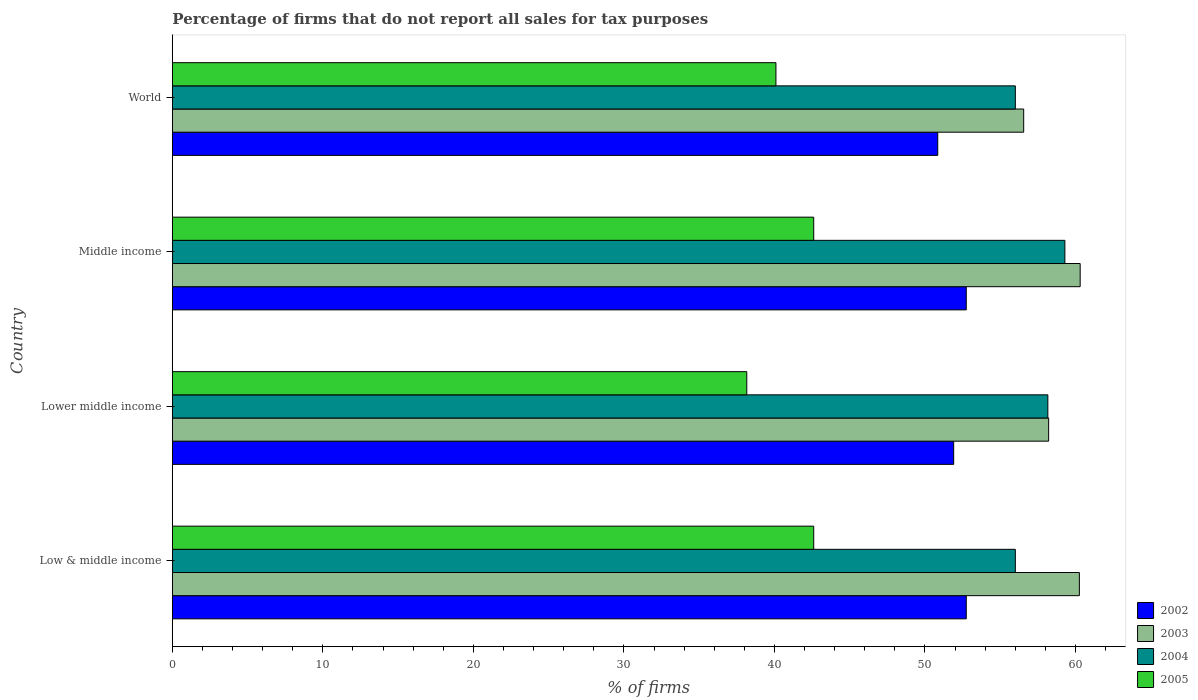Are the number of bars on each tick of the Y-axis equal?
Make the answer very short. Yes. How many bars are there on the 3rd tick from the bottom?
Offer a terse response. 4. What is the label of the 3rd group of bars from the top?
Ensure brevity in your answer.  Lower middle income. What is the percentage of firms that do not report all sales for tax purposes in 2002 in World?
Offer a very short reply. 50.85. Across all countries, what is the maximum percentage of firms that do not report all sales for tax purposes in 2004?
Provide a succinct answer. 59.3. Across all countries, what is the minimum percentage of firms that do not report all sales for tax purposes in 2002?
Provide a succinct answer. 50.85. In which country was the percentage of firms that do not report all sales for tax purposes in 2005 minimum?
Make the answer very short. Lower middle income. What is the total percentage of firms that do not report all sales for tax purposes in 2005 in the graph?
Provide a succinct answer. 163.48. What is the difference between the percentage of firms that do not report all sales for tax purposes in 2003 in Low & middle income and that in Lower middle income?
Provide a short and direct response. 2.04. What is the difference between the percentage of firms that do not report all sales for tax purposes in 2002 in Lower middle income and the percentage of firms that do not report all sales for tax purposes in 2003 in Middle income?
Offer a terse response. -8.4. What is the average percentage of firms that do not report all sales for tax purposes in 2003 per country?
Make the answer very short. 58.84. What is the difference between the percentage of firms that do not report all sales for tax purposes in 2003 and percentage of firms that do not report all sales for tax purposes in 2002 in World?
Your response must be concise. 5.71. In how many countries, is the percentage of firms that do not report all sales for tax purposes in 2002 greater than 26 %?
Offer a very short reply. 4. What is the ratio of the percentage of firms that do not report all sales for tax purposes in 2004 in Lower middle income to that in Middle income?
Your answer should be compact. 0.98. What is the difference between the highest and the second highest percentage of firms that do not report all sales for tax purposes in 2002?
Provide a succinct answer. 0. What is the difference between the highest and the lowest percentage of firms that do not report all sales for tax purposes in 2003?
Offer a very short reply. 3.75. In how many countries, is the percentage of firms that do not report all sales for tax purposes in 2005 greater than the average percentage of firms that do not report all sales for tax purposes in 2005 taken over all countries?
Make the answer very short. 2. Is the sum of the percentage of firms that do not report all sales for tax purposes in 2003 in Lower middle income and World greater than the maximum percentage of firms that do not report all sales for tax purposes in 2005 across all countries?
Provide a succinct answer. Yes. What does the 1st bar from the bottom in World represents?
Provide a succinct answer. 2002. Is it the case that in every country, the sum of the percentage of firms that do not report all sales for tax purposes in 2004 and percentage of firms that do not report all sales for tax purposes in 2005 is greater than the percentage of firms that do not report all sales for tax purposes in 2003?
Ensure brevity in your answer.  Yes. How many bars are there?
Your answer should be compact. 16. Are all the bars in the graph horizontal?
Provide a short and direct response. Yes. What is the difference between two consecutive major ticks on the X-axis?
Offer a terse response. 10. Are the values on the major ticks of X-axis written in scientific E-notation?
Your answer should be compact. No. Does the graph contain any zero values?
Offer a very short reply. No. Does the graph contain grids?
Make the answer very short. No. What is the title of the graph?
Your response must be concise. Percentage of firms that do not report all sales for tax purposes. Does "2013" appear as one of the legend labels in the graph?
Provide a short and direct response. No. What is the label or title of the X-axis?
Give a very brief answer. % of firms. What is the % of firms in 2002 in Low & middle income?
Ensure brevity in your answer.  52.75. What is the % of firms in 2003 in Low & middle income?
Provide a short and direct response. 60.26. What is the % of firms of 2004 in Low & middle income?
Offer a terse response. 56.01. What is the % of firms of 2005 in Low & middle income?
Provide a succinct answer. 42.61. What is the % of firms of 2002 in Lower middle income?
Provide a succinct answer. 51.91. What is the % of firms of 2003 in Lower middle income?
Provide a succinct answer. 58.22. What is the % of firms of 2004 in Lower middle income?
Make the answer very short. 58.16. What is the % of firms of 2005 in Lower middle income?
Your answer should be very brief. 38.16. What is the % of firms in 2002 in Middle income?
Offer a terse response. 52.75. What is the % of firms in 2003 in Middle income?
Make the answer very short. 60.31. What is the % of firms in 2004 in Middle income?
Make the answer very short. 59.3. What is the % of firms in 2005 in Middle income?
Give a very brief answer. 42.61. What is the % of firms in 2002 in World?
Your answer should be very brief. 50.85. What is the % of firms of 2003 in World?
Keep it short and to the point. 56.56. What is the % of firms of 2004 in World?
Offer a terse response. 56.01. What is the % of firms of 2005 in World?
Your answer should be compact. 40.1. Across all countries, what is the maximum % of firms of 2002?
Your response must be concise. 52.75. Across all countries, what is the maximum % of firms of 2003?
Provide a succinct answer. 60.31. Across all countries, what is the maximum % of firms of 2004?
Provide a succinct answer. 59.3. Across all countries, what is the maximum % of firms of 2005?
Give a very brief answer. 42.61. Across all countries, what is the minimum % of firms in 2002?
Keep it short and to the point. 50.85. Across all countries, what is the minimum % of firms in 2003?
Ensure brevity in your answer.  56.56. Across all countries, what is the minimum % of firms of 2004?
Offer a very short reply. 56.01. Across all countries, what is the minimum % of firms of 2005?
Give a very brief answer. 38.16. What is the total % of firms of 2002 in the graph?
Keep it short and to the point. 208.25. What is the total % of firms in 2003 in the graph?
Keep it short and to the point. 235.35. What is the total % of firms of 2004 in the graph?
Your response must be concise. 229.47. What is the total % of firms in 2005 in the graph?
Make the answer very short. 163.48. What is the difference between the % of firms of 2002 in Low & middle income and that in Lower middle income?
Your answer should be compact. 0.84. What is the difference between the % of firms of 2003 in Low & middle income and that in Lower middle income?
Offer a terse response. 2.04. What is the difference between the % of firms of 2004 in Low & middle income and that in Lower middle income?
Ensure brevity in your answer.  -2.16. What is the difference between the % of firms in 2005 in Low & middle income and that in Lower middle income?
Offer a terse response. 4.45. What is the difference between the % of firms of 2002 in Low & middle income and that in Middle income?
Your response must be concise. 0. What is the difference between the % of firms of 2003 in Low & middle income and that in Middle income?
Offer a terse response. -0.05. What is the difference between the % of firms of 2004 in Low & middle income and that in Middle income?
Your response must be concise. -3.29. What is the difference between the % of firms in 2005 in Low & middle income and that in Middle income?
Your response must be concise. 0. What is the difference between the % of firms in 2002 in Low & middle income and that in World?
Your response must be concise. 1.89. What is the difference between the % of firms in 2005 in Low & middle income and that in World?
Keep it short and to the point. 2.51. What is the difference between the % of firms in 2002 in Lower middle income and that in Middle income?
Ensure brevity in your answer.  -0.84. What is the difference between the % of firms of 2003 in Lower middle income and that in Middle income?
Make the answer very short. -2.09. What is the difference between the % of firms in 2004 in Lower middle income and that in Middle income?
Your answer should be very brief. -1.13. What is the difference between the % of firms of 2005 in Lower middle income and that in Middle income?
Give a very brief answer. -4.45. What is the difference between the % of firms in 2002 in Lower middle income and that in World?
Your answer should be very brief. 1.06. What is the difference between the % of firms of 2003 in Lower middle income and that in World?
Keep it short and to the point. 1.66. What is the difference between the % of firms of 2004 in Lower middle income and that in World?
Your response must be concise. 2.16. What is the difference between the % of firms of 2005 in Lower middle income and that in World?
Your answer should be very brief. -1.94. What is the difference between the % of firms in 2002 in Middle income and that in World?
Make the answer very short. 1.89. What is the difference between the % of firms in 2003 in Middle income and that in World?
Your response must be concise. 3.75. What is the difference between the % of firms in 2004 in Middle income and that in World?
Provide a succinct answer. 3.29. What is the difference between the % of firms of 2005 in Middle income and that in World?
Keep it short and to the point. 2.51. What is the difference between the % of firms of 2002 in Low & middle income and the % of firms of 2003 in Lower middle income?
Make the answer very short. -5.47. What is the difference between the % of firms of 2002 in Low & middle income and the % of firms of 2004 in Lower middle income?
Keep it short and to the point. -5.42. What is the difference between the % of firms of 2002 in Low & middle income and the % of firms of 2005 in Lower middle income?
Keep it short and to the point. 14.58. What is the difference between the % of firms of 2003 in Low & middle income and the % of firms of 2004 in Lower middle income?
Provide a short and direct response. 2.1. What is the difference between the % of firms of 2003 in Low & middle income and the % of firms of 2005 in Lower middle income?
Provide a succinct answer. 22.1. What is the difference between the % of firms of 2004 in Low & middle income and the % of firms of 2005 in Lower middle income?
Provide a short and direct response. 17.84. What is the difference between the % of firms in 2002 in Low & middle income and the % of firms in 2003 in Middle income?
Offer a very short reply. -7.57. What is the difference between the % of firms in 2002 in Low & middle income and the % of firms in 2004 in Middle income?
Offer a terse response. -6.55. What is the difference between the % of firms in 2002 in Low & middle income and the % of firms in 2005 in Middle income?
Your answer should be compact. 10.13. What is the difference between the % of firms in 2003 in Low & middle income and the % of firms in 2004 in Middle income?
Provide a succinct answer. 0.96. What is the difference between the % of firms in 2003 in Low & middle income and the % of firms in 2005 in Middle income?
Provide a short and direct response. 17.65. What is the difference between the % of firms in 2004 in Low & middle income and the % of firms in 2005 in Middle income?
Provide a short and direct response. 13.39. What is the difference between the % of firms of 2002 in Low & middle income and the % of firms of 2003 in World?
Keep it short and to the point. -3.81. What is the difference between the % of firms of 2002 in Low & middle income and the % of firms of 2004 in World?
Offer a terse response. -3.26. What is the difference between the % of firms in 2002 in Low & middle income and the % of firms in 2005 in World?
Your answer should be very brief. 12.65. What is the difference between the % of firms of 2003 in Low & middle income and the % of firms of 2004 in World?
Your answer should be very brief. 4.25. What is the difference between the % of firms of 2003 in Low & middle income and the % of firms of 2005 in World?
Offer a very short reply. 20.16. What is the difference between the % of firms in 2004 in Low & middle income and the % of firms in 2005 in World?
Your answer should be compact. 15.91. What is the difference between the % of firms in 2002 in Lower middle income and the % of firms in 2003 in Middle income?
Keep it short and to the point. -8.4. What is the difference between the % of firms in 2002 in Lower middle income and the % of firms in 2004 in Middle income?
Give a very brief answer. -7.39. What is the difference between the % of firms in 2002 in Lower middle income and the % of firms in 2005 in Middle income?
Your answer should be compact. 9.3. What is the difference between the % of firms in 2003 in Lower middle income and the % of firms in 2004 in Middle income?
Your answer should be very brief. -1.08. What is the difference between the % of firms in 2003 in Lower middle income and the % of firms in 2005 in Middle income?
Your response must be concise. 15.61. What is the difference between the % of firms of 2004 in Lower middle income and the % of firms of 2005 in Middle income?
Provide a succinct answer. 15.55. What is the difference between the % of firms of 2002 in Lower middle income and the % of firms of 2003 in World?
Your answer should be very brief. -4.65. What is the difference between the % of firms of 2002 in Lower middle income and the % of firms of 2004 in World?
Your response must be concise. -4.1. What is the difference between the % of firms in 2002 in Lower middle income and the % of firms in 2005 in World?
Your answer should be very brief. 11.81. What is the difference between the % of firms in 2003 in Lower middle income and the % of firms in 2004 in World?
Make the answer very short. 2.21. What is the difference between the % of firms of 2003 in Lower middle income and the % of firms of 2005 in World?
Make the answer very short. 18.12. What is the difference between the % of firms of 2004 in Lower middle income and the % of firms of 2005 in World?
Give a very brief answer. 18.07. What is the difference between the % of firms in 2002 in Middle income and the % of firms in 2003 in World?
Offer a very short reply. -3.81. What is the difference between the % of firms in 2002 in Middle income and the % of firms in 2004 in World?
Provide a short and direct response. -3.26. What is the difference between the % of firms of 2002 in Middle income and the % of firms of 2005 in World?
Keep it short and to the point. 12.65. What is the difference between the % of firms in 2003 in Middle income and the % of firms in 2004 in World?
Ensure brevity in your answer.  4.31. What is the difference between the % of firms of 2003 in Middle income and the % of firms of 2005 in World?
Provide a succinct answer. 20.21. What is the difference between the % of firms of 2004 in Middle income and the % of firms of 2005 in World?
Provide a succinct answer. 19.2. What is the average % of firms of 2002 per country?
Keep it short and to the point. 52.06. What is the average % of firms of 2003 per country?
Your answer should be compact. 58.84. What is the average % of firms of 2004 per country?
Ensure brevity in your answer.  57.37. What is the average % of firms in 2005 per country?
Your response must be concise. 40.87. What is the difference between the % of firms in 2002 and % of firms in 2003 in Low & middle income?
Provide a short and direct response. -7.51. What is the difference between the % of firms in 2002 and % of firms in 2004 in Low & middle income?
Your answer should be very brief. -3.26. What is the difference between the % of firms in 2002 and % of firms in 2005 in Low & middle income?
Provide a succinct answer. 10.13. What is the difference between the % of firms in 2003 and % of firms in 2004 in Low & middle income?
Your answer should be compact. 4.25. What is the difference between the % of firms in 2003 and % of firms in 2005 in Low & middle income?
Provide a succinct answer. 17.65. What is the difference between the % of firms in 2004 and % of firms in 2005 in Low & middle income?
Provide a succinct answer. 13.39. What is the difference between the % of firms of 2002 and % of firms of 2003 in Lower middle income?
Offer a terse response. -6.31. What is the difference between the % of firms in 2002 and % of firms in 2004 in Lower middle income?
Ensure brevity in your answer.  -6.26. What is the difference between the % of firms in 2002 and % of firms in 2005 in Lower middle income?
Ensure brevity in your answer.  13.75. What is the difference between the % of firms of 2003 and % of firms of 2004 in Lower middle income?
Ensure brevity in your answer.  0.05. What is the difference between the % of firms in 2003 and % of firms in 2005 in Lower middle income?
Give a very brief answer. 20.06. What is the difference between the % of firms of 2004 and % of firms of 2005 in Lower middle income?
Give a very brief answer. 20. What is the difference between the % of firms in 2002 and % of firms in 2003 in Middle income?
Your answer should be very brief. -7.57. What is the difference between the % of firms in 2002 and % of firms in 2004 in Middle income?
Provide a short and direct response. -6.55. What is the difference between the % of firms in 2002 and % of firms in 2005 in Middle income?
Your answer should be compact. 10.13. What is the difference between the % of firms in 2003 and % of firms in 2004 in Middle income?
Provide a short and direct response. 1.02. What is the difference between the % of firms in 2003 and % of firms in 2005 in Middle income?
Your answer should be very brief. 17.7. What is the difference between the % of firms of 2004 and % of firms of 2005 in Middle income?
Make the answer very short. 16.69. What is the difference between the % of firms in 2002 and % of firms in 2003 in World?
Make the answer very short. -5.71. What is the difference between the % of firms of 2002 and % of firms of 2004 in World?
Keep it short and to the point. -5.15. What is the difference between the % of firms of 2002 and % of firms of 2005 in World?
Keep it short and to the point. 10.75. What is the difference between the % of firms in 2003 and % of firms in 2004 in World?
Your response must be concise. 0.56. What is the difference between the % of firms in 2003 and % of firms in 2005 in World?
Offer a terse response. 16.46. What is the difference between the % of firms in 2004 and % of firms in 2005 in World?
Keep it short and to the point. 15.91. What is the ratio of the % of firms in 2002 in Low & middle income to that in Lower middle income?
Make the answer very short. 1.02. What is the ratio of the % of firms of 2003 in Low & middle income to that in Lower middle income?
Your answer should be very brief. 1.04. What is the ratio of the % of firms in 2004 in Low & middle income to that in Lower middle income?
Offer a very short reply. 0.96. What is the ratio of the % of firms in 2005 in Low & middle income to that in Lower middle income?
Your answer should be compact. 1.12. What is the ratio of the % of firms of 2002 in Low & middle income to that in Middle income?
Provide a succinct answer. 1. What is the ratio of the % of firms in 2004 in Low & middle income to that in Middle income?
Keep it short and to the point. 0.94. What is the ratio of the % of firms in 2005 in Low & middle income to that in Middle income?
Make the answer very short. 1. What is the ratio of the % of firms of 2002 in Low & middle income to that in World?
Make the answer very short. 1.04. What is the ratio of the % of firms of 2003 in Low & middle income to that in World?
Ensure brevity in your answer.  1.07. What is the ratio of the % of firms in 2005 in Low & middle income to that in World?
Offer a very short reply. 1.06. What is the ratio of the % of firms in 2002 in Lower middle income to that in Middle income?
Provide a short and direct response. 0.98. What is the ratio of the % of firms of 2003 in Lower middle income to that in Middle income?
Your answer should be very brief. 0.97. What is the ratio of the % of firms in 2004 in Lower middle income to that in Middle income?
Your response must be concise. 0.98. What is the ratio of the % of firms in 2005 in Lower middle income to that in Middle income?
Give a very brief answer. 0.9. What is the ratio of the % of firms of 2002 in Lower middle income to that in World?
Offer a terse response. 1.02. What is the ratio of the % of firms of 2003 in Lower middle income to that in World?
Your answer should be very brief. 1.03. What is the ratio of the % of firms in 2004 in Lower middle income to that in World?
Give a very brief answer. 1.04. What is the ratio of the % of firms of 2005 in Lower middle income to that in World?
Offer a terse response. 0.95. What is the ratio of the % of firms of 2002 in Middle income to that in World?
Your response must be concise. 1.04. What is the ratio of the % of firms in 2003 in Middle income to that in World?
Your answer should be compact. 1.07. What is the ratio of the % of firms in 2004 in Middle income to that in World?
Your answer should be compact. 1.06. What is the ratio of the % of firms in 2005 in Middle income to that in World?
Your answer should be compact. 1.06. What is the difference between the highest and the second highest % of firms of 2003?
Provide a succinct answer. 0.05. What is the difference between the highest and the second highest % of firms in 2004?
Your response must be concise. 1.13. What is the difference between the highest and the second highest % of firms of 2005?
Your answer should be very brief. 0. What is the difference between the highest and the lowest % of firms of 2002?
Your answer should be very brief. 1.89. What is the difference between the highest and the lowest % of firms of 2003?
Offer a very short reply. 3.75. What is the difference between the highest and the lowest % of firms in 2004?
Offer a terse response. 3.29. What is the difference between the highest and the lowest % of firms of 2005?
Your answer should be very brief. 4.45. 